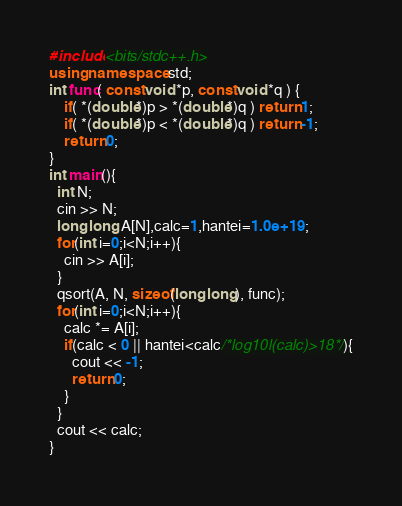Convert code to text. <code><loc_0><loc_0><loc_500><loc_500><_C++_>#include<bits/stdc++.h>
using namespace std;
int func( const void *p, const void *q ) {
    if( *(double*)p > *(double*)q ) return 1;
    if( *(double*)p < *(double*)q ) return -1;
    return 0;
}
int main(){
  int N;
  cin >> N;
  long long A[N],calc=1,hantei=1.0e+19;
  for(int i=0;i<N;i++){
    cin >> A[i];
  }
  qsort(A, N, sizeof(long long), func);
  for(int i=0;i<N;i++){
    calc *= A[i];
    if(calc < 0 || hantei<calc/*log10l(calc)>18*/){
      cout << -1;
      return 0;
    }
  }
  cout << calc;
}
</code> 